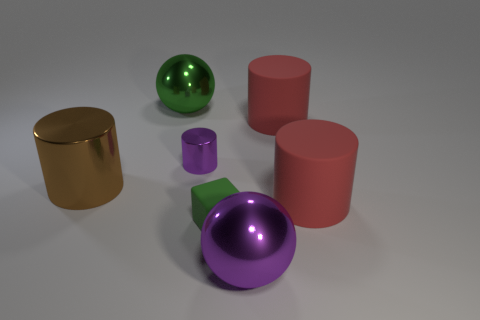Are there any other things that have the same color as the matte block?
Offer a very short reply. Yes. What number of small green matte things are there?
Provide a short and direct response. 1. There is a green object in front of the green thing to the left of the tiny metallic cylinder; what is its material?
Your answer should be very brief. Rubber. The large matte cylinder that is in front of the purple object that is behind the purple object in front of the small green matte cube is what color?
Ensure brevity in your answer.  Red. What number of other metallic things have the same size as the brown thing?
Keep it short and to the point. 2. Is the number of cylinders on the left side of the tiny purple shiny cylinder greater than the number of brown metallic things that are to the left of the large brown cylinder?
Your answer should be compact. Yes. The large rubber cylinder left of the large red rubber cylinder in front of the tiny cylinder is what color?
Your answer should be compact. Red. Is the small cylinder made of the same material as the big brown object?
Offer a terse response. Yes. Is there a large purple thing of the same shape as the big brown metal object?
Make the answer very short. No. Is the color of the big metal object in front of the green cube the same as the small metallic thing?
Provide a succinct answer. Yes. 